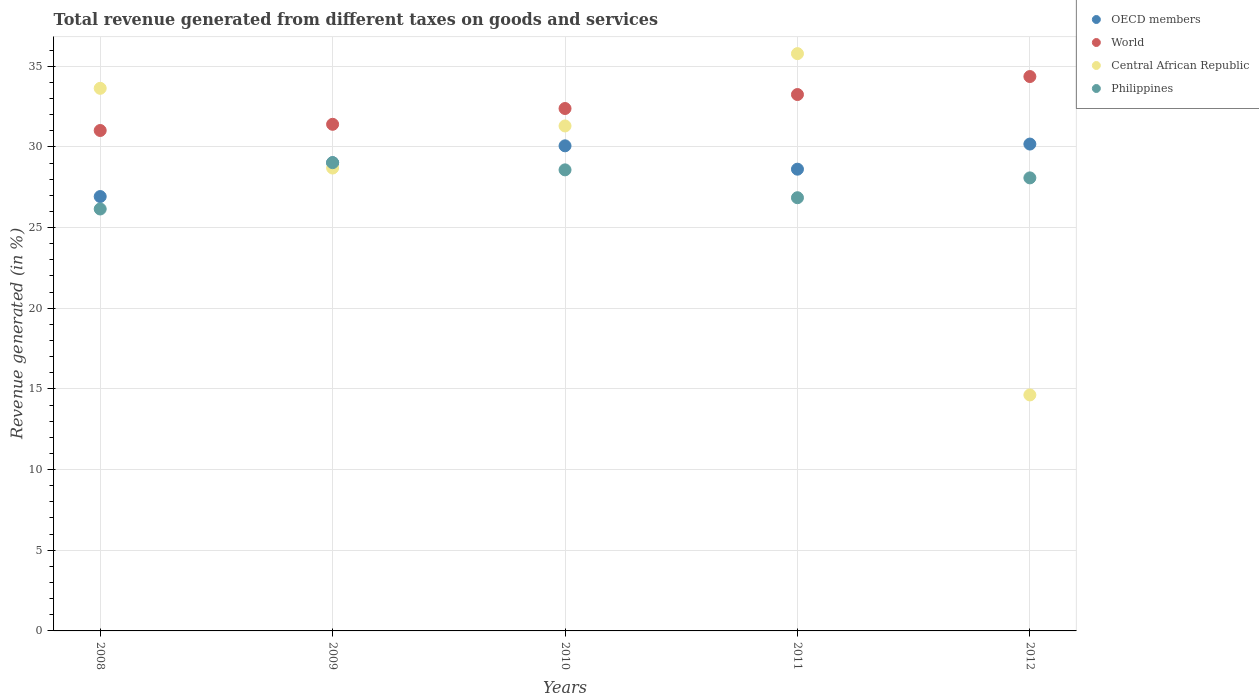What is the total revenue generated in World in 2012?
Your answer should be very brief. 34.36. Across all years, what is the maximum total revenue generated in Central African Republic?
Offer a very short reply. 35.78. Across all years, what is the minimum total revenue generated in Philippines?
Make the answer very short. 26.15. In which year was the total revenue generated in Central African Republic maximum?
Keep it short and to the point. 2011. What is the total total revenue generated in OECD members in the graph?
Your response must be concise. 144.8. What is the difference between the total revenue generated in Central African Republic in 2009 and that in 2010?
Keep it short and to the point. -2.61. What is the difference between the total revenue generated in OECD members in 2011 and the total revenue generated in Philippines in 2010?
Offer a terse response. 0.04. What is the average total revenue generated in Central African Republic per year?
Make the answer very short. 28.8. In the year 2011, what is the difference between the total revenue generated in Central African Republic and total revenue generated in Philippines?
Your answer should be compact. 8.93. In how many years, is the total revenue generated in OECD members greater than 32 %?
Your answer should be very brief. 0. What is the ratio of the total revenue generated in World in 2011 to that in 2012?
Your answer should be compact. 0.97. Is the total revenue generated in World in 2011 less than that in 2012?
Offer a terse response. Yes. Is the difference between the total revenue generated in Central African Republic in 2008 and 2010 greater than the difference between the total revenue generated in Philippines in 2008 and 2010?
Make the answer very short. Yes. What is the difference between the highest and the second highest total revenue generated in World?
Your response must be concise. 1.12. What is the difference between the highest and the lowest total revenue generated in Central African Republic?
Provide a short and direct response. 21.15. Does the total revenue generated in Philippines monotonically increase over the years?
Your answer should be very brief. No. How many years are there in the graph?
Your answer should be compact. 5. What is the difference between two consecutive major ticks on the Y-axis?
Provide a short and direct response. 5. Are the values on the major ticks of Y-axis written in scientific E-notation?
Offer a terse response. No. How many legend labels are there?
Ensure brevity in your answer.  4. What is the title of the graph?
Ensure brevity in your answer.  Total revenue generated from different taxes on goods and services. Does "Venezuela" appear as one of the legend labels in the graph?
Make the answer very short. No. What is the label or title of the Y-axis?
Ensure brevity in your answer.  Revenue generated (in %). What is the Revenue generated (in %) of OECD members in 2008?
Your answer should be very brief. 26.92. What is the Revenue generated (in %) in World in 2008?
Offer a terse response. 31.02. What is the Revenue generated (in %) of Central African Republic in 2008?
Offer a very short reply. 33.63. What is the Revenue generated (in %) of Philippines in 2008?
Offer a terse response. 26.15. What is the Revenue generated (in %) of OECD members in 2009?
Ensure brevity in your answer.  29.02. What is the Revenue generated (in %) in World in 2009?
Make the answer very short. 31.4. What is the Revenue generated (in %) of Central African Republic in 2009?
Ensure brevity in your answer.  28.69. What is the Revenue generated (in %) in Philippines in 2009?
Make the answer very short. 29.02. What is the Revenue generated (in %) in OECD members in 2010?
Your answer should be very brief. 30.07. What is the Revenue generated (in %) in World in 2010?
Make the answer very short. 32.38. What is the Revenue generated (in %) in Central African Republic in 2010?
Your response must be concise. 31.3. What is the Revenue generated (in %) of Philippines in 2010?
Keep it short and to the point. 28.58. What is the Revenue generated (in %) of OECD members in 2011?
Your answer should be very brief. 28.62. What is the Revenue generated (in %) of World in 2011?
Your answer should be very brief. 33.24. What is the Revenue generated (in %) in Central African Republic in 2011?
Make the answer very short. 35.78. What is the Revenue generated (in %) in Philippines in 2011?
Offer a terse response. 26.85. What is the Revenue generated (in %) in OECD members in 2012?
Your answer should be very brief. 30.17. What is the Revenue generated (in %) of World in 2012?
Your answer should be compact. 34.36. What is the Revenue generated (in %) in Central African Republic in 2012?
Your answer should be very brief. 14.63. What is the Revenue generated (in %) in Philippines in 2012?
Offer a terse response. 28.08. Across all years, what is the maximum Revenue generated (in %) of OECD members?
Provide a succinct answer. 30.17. Across all years, what is the maximum Revenue generated (in %) in World?
Ensure brevity in your answer.  34.36. Across all years, what is the maximum Revenue generated (in %) in Central African Republic?
Give a very brief answer. 35.78. Across all years, what is the maximum Revenue generated (in %) in Philippines?
Provide a short and direct response. 29.02. Across all years, what is the minimum Revenue generated (in %) in OECD members?
Offer a terse response. 26.92. Across all years, what is the minimum Revenue generated (in %) of World?
Your answer should be very brief. 31.02. Across all years, what is the minimum Revenue generated (in %) of Central African Republic?
Offer a terse response. 14.63. Across all years, what is the minimum Revenue generated (in %) of Philippines?
Your answer should be compact. 26.15. What is the total Revenue generated (in %) in OECD members in the graph?
Offer a terse response. 144.8. What is the total Revenue generated (in %) in World in the graph?
Your answer should be compact. 162.4. What is the total Revenue generated (in %) of Central African Republic in the graph?
Provide a succinct answer. 144.02. What is the total Revenue generated (in %) of Philippines in the graph?
Make the answer very short. 138.68. What is the difference between the Revenue generated (in %) of OECD members in 2008 and that in 2009?
Your response must be concise. -2.1. What is the difference between the Revenue generated (in %) in World in 2008 and that in 2009?
Your answer should be compact. -0.38. What is the difference between the Revenue generated (in %) in Central African Republic in 2008 and that in 2009?
Give a very brief answer. 4.94. What is the difference between the Revenue generated (in %) of Philippines in 2008 and that in 2009?
Your response must be concise. -2.87. What is the difference between the Revenue generated (in %) of OECD members in 2008 and that in 2010?
Your answer should be very brief. -3.14. What is the difference between the Revenue generated (in %) in World in 2008 and that in 2010?
Give a very brief answer. -1.36. What is the difference between the Revenue generated (in %) in Central African Republic in 2008 and that in 2010?
Offer a terse response. 2.33. What is the difference between the Revenue generated (in %) of Philippines in 2008 and that in 2010?
Offer a terse response. -2.42. What is the difference between the Revenue generated (in %) in OECD members in 2008 and that in 2011?
Your answer should be very brief. -1.7. What is the difference between the Revenue generated (in %) in World in 2008 and that in 2011?
Offer a terse response. -2.23. What is the difference between the Revenue generated (in %) of Central African Republic in 2008 and that in 2011?
Keep it short and to the point. -2.15. What is the difference between the Revenue generated (in %) of Philippines in 2008 and that in 2011?
Ensure brevity in your answer.  -0.7. What is the difference between the Revenue generated (in %) in OECD members in 2008 and that in 2012?
Offer a very short reply. -3.25. What is the difference between the Revenue generated (in %) in World in 2008 and that in 2012?
Keep it short and to the point. -3.34. What is the difference between the Revenue generated (in %) of Central African Republic in 2008 and that in 2012?
Offer a very short reply. 19. What is the difference between the Revenue generated (in %) in Philippines in 2008 and that in 2012?
Keep it short and to the point. -1.93. What is the difference between the Revenue generated (in %) in OECD members in 2009 and that in 2010?
Make the answer very short. -1.05. What is the difference between the Revenue generated (in %) in World in 2009 and that in 2010?
Your answer should be compact. -0.98. What is the difference between the Revenue generated (in %) in Central African Republic in 2009 and that in 2010?
Offer a very short reply. -2.61. What is the difference between the Revenue generated (in %) of Philippines in 2009 and that in 2010?
Your answer should be very brief. 0.45. What is the difference between the Revenue generated (in %) of OECD members in 2009 and that in 2011?
Provide a short and direct response. 0.4. What is the difference between the Revenue generated (in %) in World in 2009 and that in 2011?
Your answer should be compact. -1.85. What is the difference between the Revenue generated (in %) of Central African Republic in 2009 and that in 2011?
Offer a very short reply. -7.09. What is the difference between the Revenue generated (in %) of Philippines in 2009 and that in 2011?
Make the answer very short. 2.17. What is the difference between the Revenue generated (in %) of OECD members in 2009 and that in 2012?
Make the answer very short. -1.16. What is the difference between the Revenue generated (in %) of World in 2009 and that in 2012?
Your response must be concise. -2.96. What is the difference between the Revenue generated (in %) of Central African Republic in 2009 and that in 2012?
Ensure brevity in your answer.  14.06. What is the difference between the Revenue generated (in %) in Philippines in 2009 and that in 2012?
Your answer should be compact. 0.94. What is the difference between the Revenue generated (in %) of OECD members in 2010 and that in 2011?
Your answer should be compact. 1.45. What is the difference between the Revenue generated (in %) of World in 2010 and that in 2011?
Keep it short and to the point. -0.87. What is the difference between the Revenue generated (in %) in Central African Republic in 2010 and that in 2011?
Offer a very short reply. -4.48. What is the difference between the Revenue generated (in %) in Philippines in 2010 and that in 2011?
Ensure brevity in your answer.  1.73. What is the difference between the Revenue generated (in %) in OECD members in 2010 and that in 2012?
Make the answer very short. -0.11. What is the difference between the Revenue generated (in %) in World in 2010 and that in 2012?
Offer a terse response. -1.98. What is the difference between the Revenue generated (in %) of Central African Republic in 2010 and that in 2012?
Provide a short and direct response. 16.67. What is the difference between the Revenue generated (in %) of Philippines in 2010 and that in 2012?
Your response must be concise. 0.5. What is the difference between the Revenue generated (in %) in OECD members in 2011 and that in 2012?
Your answer should be very brief. -1.56. What is the difference between the Revenue generated (in %) of World in 2011 and that in 2012?
Make the answer very short. -1.11. What is the difference between the Revenue generated (in %) in Central African Republic in 2011 and that in 2012?
Offer a terse response. 21.15. What is the difference between the Revenue generated (in %) of Philippines in 2011 and that in 2012?
Keep it short and to the point. -1.23. What is the difference between the Revenue generated (in %) of OECD members in 2008 and the Revenue generated (in %) of World in 2009?
Provide a succinct answer. -4.48. What is the difference between the Revenue generated (in %) of OECD members in 2008 and the Revenue generated (in %) of Central African Republic in 2009?
Ensure brevity in your answer.  -1.77. What is the difference between the Revenue generated (in %) of OECD members in 2008 and the Revenue generated (in %) of Philippines in 2009?
Keep it short and to the point. -2.1. What is the difference between the Revenue generated (in %) of World in 2008 and the Revenue generated (in %) of Central African Republic in 2009?
Your answer should be compact. 2.33. What is the difference between the Revenue generated (in %) of World in 2008 and the Revenue generated (in %) of Philippines in 2009?
Provide a short and direct response. 1.99. What is the difference between the Revenue generated (in %) of Central African Republic in 2008 and the Revenue generated (in %) of Philippines in 2009?
Your answer should be compact. 4.61. What is the difference between the Revenue generated (in %) of OECD members in 2008 and the Revenue generated (in %) of World in 2010?
Provide a short and direct response. -5.46. What is the difference between the Revenue generated (in %) of OECD members in 2008 and the Revenue generated (in %) of Central African Republic in 2010?
Provide a short and direct response. -4.38. What is the difference between the Revenue generated (in %) in OECD members in 2008 and the Revenue generated (in %) in Philippines in 2010?
Your answer should be very brief. -1.65. What is the difference between the Revenue generated (in %) of World in 2008 and the Revenue generated (in %) of Central African Republic in 2010?
Make the answer very short. -0.28. What is the difference between the Revenue generated (in %) in World in 2008 and the Revenue generated (in %) in Philippines in 2010?
Give a very brief answer. 2.44. What is the difference between the Revenue generated (in %) in Central African Republic in 2008 and the Revenue generated (in %) in Philippines in 2010?
Ensure brevity in your answer.  5.05. What is the difference between the Revenue generated (in %) in OECD members in 2008 and the Revenue generated (in %) in World in 2011?
Offer a very short reply. -6.32. What is the difference between the Revenue generated (in %) in OECD members in 2008 and the Revenue generated (in %) in Central African Republic in 2011?
Give a very brief answer. -8.86. What is the difference between the Revenue generated (in %) in OECD members in 2008 and the Revenue generated (in %) in Philippines in 2011?
Make the answer very short. 0.07. What is the difference between the Revenue generated (in %) in World in 2008 and the Revenue generated (in %) in Central African Republic in 2011?
Provide a succinct answer. -4.76. What is the difference between the Revenue generated (in %) in World in 2008 and the Revenue generated (in %) in Philippines in 2011?
Provide a short and direct response. 4.17. What is the difference between the Revenue generated (in %) of Central African Republic in 2008 and the Revenue generated (in %) of Philippines in 2011?
Provide a short and direct response. 6.78. What is the difference between the Revenue generated (in %) of OECD members in 2008 and the Revenue generated (in %) of World in 2012?
Make the answer very short. -7.44. What is the difference between the Revenue generated (in %) in OECD members in 2008 and the Revenue generated (in %) in Central African Republic in 2012?
Offer a very short reply. 12.3. What is the difference between the Revenue generated (in %) in OECD members in 2008 and the Revenue generated (in %) in Philippines in 2012?
Your response must be concise. -1.16. What is the difference between the Revenue generated (in %) of World in 2008 and the Revenue generated (in %) of Central African Republic in 2012?
Keep it short and to the point. 16.39. What is the difference between the Revenue generated (in %) of World in 2008 and the Revenue generated (in %) of Philippines in 2012?
Offer a terse response. 2.94. What is the difference between the Revenue generated (in %) in Central African Republic in 2008 and the Revenue generated (in %) in Philippines in 2012?
Give a very brief answer. 5.55. What is the difference between the Revenue generated (in %) of OECD members in 2009 and the Revenue generated (in %) of World in 2010?
Give a very brief answer. -3.36. What is the difference between the Revenue generated (in %) in OECD members in 2009 and the Revenue generated (in %) in Central African Republic in 2010?
Keep it short and to the point. -2.28. What is the difference between the Revenue generated (in %) of OECD members in 2009 and the Revenue generated (in %) of Philippines in 2010?
Make the answer very short. 0.44. What is the difference between the Revenue generated (in %) in World in 2009 and the Revenue generated (in %) in Central African Republic in 2010?
Your answer should be very brief. 0.1. What is the difference between the Revenue generated (in %) in World in 2009 and the Revenue generated (in %) in Philippines in 2010?
Ensure brevity in your answer.  2.82. What is the difference between the Revenue generated (in %) of Central African Republic in 2009 and the Revenue generated (in %) of Philippines in 2010?
Your answer should be compact. 0.11. What is the difference between the Revenue generated (in %) of OECD members in 2009 and the Revenue generated (in %) of World in 2011?
Keep it short and to the point. -4.23. What is the difference between the Revenue generated (in %) of OECD members in 2009 and the Revenue generated (in %) of Central African Republic in 2011?
Your response must be concise. -6.76. What is the difference between the Revenue generated (in %) of OECD members in 2009 and the Revenue generated (in %) of Philippines in 2011?
Make the answer very short. 2.17. What is the difference between the Revenue generated (in %) of World in 2009 and the Revenue generated (in %) of Central African Republic in 2011?
Your answer should be compact. -4.38. What is the difference between the Revenue generated (in %) of World in 2009 and the Revenue generated (in %) of Philippines in 2011?
Provide a short and direct response. 4.55. What is the difference between the Revenue generated (in %) in Central African Republic in 2009 and the Revenue generated (in %) in Philippines in 2011?
Your response must be concise. 1.84. What is the difference between the Revenue generated (in %) in OECD members in 2009 and the Revenue generated (in %) in World in 2012?
Your answer should be very brief. -5.34. What is the difference between the Revenue generated (in %) in OECD members in 2009 and the Revenue generated (in %) in Central African Republic in 2012?
Your answer should be compact. 14.39. What is the difference between the Revenue generated (in %) in OECD members in 2009 and the Revenue generated (in %) in Philippines in 2012?
Offer a very short reply. 0.94. What is the difference between the Revenue generated (in %) of World in 2009 and the Revenue generated (in %) of Central African Republic in 2012?
Your response must be concise. 16.77. What is the difference between the Revenue generated (in %) in World in 2009 and the Revenue generated (in %) in Philippines in 2012?
Your answer should be very brief. 3.32. What is the difference between the Revenue generated (in %) of Central African Republic in 2009 and the Revenue generated (in %) of Philippines in 2012?
Your response must be concise. 0.61. What is the difference between the Revenue generated (in %) of OECD members in 2010 and the Revenue generated (in %) of World in 2011?
Provide a succinct answer. -3.18. What is the difference between the Revenue generated (in %) of OECD members in 2010 and the Revenue generated (in %) of Central African Republic in 2011?
Keep it short and to the point. -5.71. What is the difference between the Revenue generated (in %) of OECD members in 2010 and the Revenue generated (in %) of Philippines in 2011?
Provide a short and direct response. 3.22. What is the difference between the Revenue generated (in %) of World in 2010 and the Revenue generated (in %) of Central African Republic in 2011?
Your answer should be compact. -3.4. What is the difference between the Revenue generated (in %) of World in 2010 and the Revenue generated (in %) of Philippines in 2011?
Your response must be concise. 5.53. What is the difference between the Revenue generated (in %) of Central African Republic in 2010 and the Revenue generated (in %) of Philippines in 2011?
Ensure brevity in your answer.  4.45. What is the difference between the Revenue generated (in %) in OECD members in 2010 and the Revenue generated (in %) in World in 2012?
Your answer should be compact. -4.29. What is the difference between the Revenue generated (in %) in OECD members in 2010 and the Revenue generated (in %) in Central African Republic in 2012?
Keep it short and to the point. 15.44. What is the difference between the Revenue generated (in %) of OECD members in 2010 and the Revenue generated (in %) of Philippines in 2012?
Make the answer very short. 1.99. What is the difference between the Revenue generated (in %) in World in 2010 and the Revenue generated (in %) in Central African Republic in 2012?
Ensure brevity in your answer.  17.75. What is the difference between the Revenue generated (in %) in World in 2010 and the Revenue generated (in %) in Philippines in 2012?
Give a very brief answer. 4.3. What is the difference between the Revenue generated (in %) of Central African Republic in 2010 and the Revenue generated (in %) of Philippines in 2012?
Offer a very short reply. 3.22. What is the difference between the Revenue generated (in %) in OECD members in 2011 and the Revenue generated (in %) in World in 2012?
Provide a succinct answer. -5.74. What is the difference between the Revenue generated (in %) of OECD members in 2011 and the Revenue generated (in %) of Central African Republic in 2012?
Give a very brief answer. 13.99. What is the difference between the Revenue generated (in %) in OECD members in 2011 and the Revenue generated (in %) in Philippines in 2012?
Give a very brief answer. 0.54. What is the difference between the Revenue generated (in %) of World in 2011 and the Revenue generated (in %) of Central African Republic in 2012?
Provide a succinct answer. 18.62. What is the difference between the Revenue generated (in %) in World in 2011 and the Revenue generated (in %) in Philippines in 2012?
Your response must be concise. 5.17. What is the difference between the Revenue generated (in %) of Central African Republic in 2011 and the Revenue generated (in %) of Philippines in 2012?
Ensure brevity in your answer.  7.7. What is the average Revenue generated (in %) of OECD members per year?
Make the answer very short. 28.96. What is the average Revenue generated (in %) in World per year?
Offer a terse response. 32.48. What is the average Revenue generated (in %) of Central African Republic per year?
Give a very brief answer. 28.8. What is the average Revenue generated (in %) in Philippines per year?
Ensure brevity in your answer.  27.74. In the year 2008, what is the difference between the Revenue generated (in %) in OECD members and Revenue generated (in %) in World?
Give a very brief answer. -4.09. In the year 2008, what is the difference between the Revenue generated (in %) of OECD members and Revenue generated (in %) of Central African Republic?
Ensure brevity in your answer.  -6.71. In the year 2008, what is the difference between the Revenue generated (in %) of OECD members and Revenue generated (in %) of Philippines?
Give a very brief answer. 0.77. In the year 2008, what is the difference between the Revenue generated (in %) of World and Revenue generated (in %) of Central African Republic?
Your response must be concise. -2.61. In the year 2008, what is the difference between the Revenue generated (in %) in World and Revenue generated (in %) in Philippines?
Offer a terse response. 4.86. In the year 2008, what is the difference between the Revenue generated (in %) in Central African Republic and Revenue generated (in %) in Philippines?
Keep it short and to the point. 7.48. In the year 2009, what is the difference between the Revenue generated (in %) of OECD members and Revenue generated (in %) of World?
Your answer should be compact. -2.38. In the year 2009, what is the difference between the Revenue generated (in %) in OECD members and Revenue generated (in %) in Central African Republic?
Provide a succinct answer. 0.33. In the year 2009, what is the difference between the Revenue generated (in %) in OECD members and Revenue generated (in %) in Philippines?
Your answer should be compact. -0. In the year 2009, what is the difference between the Revenue generated (in %) in World and Revenue generated (in %) in Central African Republic?
Make the answer very short. 2.71. In the year 2009, what is the difference between the Revenue generated (in %) of World and Revenue generated (in %) of Philippines?
Provide a succinct answer. 2.38. In the year 2009, what is the difference between the Revenue generated (in %) of Central African Republic and Revenue generated (in %) of Philippines?
Give a very brief answer. -0.33. In the year 2010, what is the difference between the Revenue generated (in %) of OECD members and Revenue generated (in %) of World?
Make the answer very short. -2.31. In the year 2010, what is the difference between the Revenue generated (in %) in OECD members and Revenue generated (in %) in Central African Republic?
Keep it short and to the point. -1.23. In the year 2010, what is the difference between the Revenue generated (in %) in OECD members and Revenue generated (in %) in Philippines?
Make the answer very short. 1.49. In the year 2010, what is the difference between the Revenue generated (in %) of World and Revenue generated (in %) of Central African Republic?
Your response must be concise. 1.08. In the year 2010, what is the difference between the Revenue generated (in %) in World and Revenue generated (in %) in Philippines?
Offer a very short reply. 3.8. In the year 2010, what is the difference between the Revenue generated (in %) of Central African Republic and Revenue generated (in %) of Philippines?
Keep it short and to the point. 2.72. In the year 2011, what is the difference between the Revenue generated (in %) in OECD members and Revenue generated (in %) in World?
Make the answer very short. -4.63. In the year 2011, what is the difference between the Revenue generated (in %) in OECD members and Revenue generated (in %) in Central African Republic?
Your response must be concise. -7.16. In the year 2011, what is the difference between the Revenue generated (in %) of OECD members and Revenue generated (in %) of Philippines?
Ensure brevity in your answer.  1.77. In the year 2011, what is the difference between the Revenue generated (in %) of World and Revenue generated (in %) of Central African Republic?
Your response must be concise. -2.53. In the year 2011, what is the difference between the Revenue generated (in %) in World and Revenue generated (in %) in Philippines?
Offer a very short reply. 6.4. In the year 2011, what is the difference between the Revenue generated (in %) of Central African Republic and Revenue generated (in %) of Philippines?
Your answer should be compact. 8.93. In the year 2012, what is the difference between the Revenue generated (in %) in OECD members and Revenue generated (in %) in World?
Offer a terse response. -4.18. In the year 2012, what is the difference between the Revenue generated (in %) of OECD members and Revenue generated (in %) of Central African Republic?
Offer a terse response. 15.55. In the year 2012, what is the difference between the Revenue generated (in %) in OECD members and Revenue generated (in %) in Philippines?
Provide a succinct answer. 2.1. In the year 2012, what is the difference between the Revenue generated (in %) in World and Revenue generated (in %) in Central African Republic?
Keep it short and to the point. 19.73. In the year 2012, what is the difference between the Revenue generated (in %) of World and Revenue generated (in %) of Philippines?
Make the answer very short. 6.28. In the year 2012, what is the difference between the Revenue generated (in %) of Central African Republic and Revenue generated (in %) of Philippines?
Provide a short and direct response. -13.45. What is the ratio of the Revenue generated (in %) of OECD members in 2008 to that in 2009?
Provide a succinct answer. 0.93. What is the ratio of the Revenue generated (in %) of Central African Republic in 2008 to that in 2009?
Your response must be concise. 1.17. What is the ratio of the Revenue generated (in %) in Philippines in 2008 to that in 2009?
Your answer should be compact. 0.9. What is the ratio of the Revenue generated (in %) of OECD members in 2008 to that in 2010?
Offer a terse response. 0.9. What is the ratio of the Revenue generated (in %) in World in 2008 to that in 2010?
Offer a terse response. 0.96. What is the ratio of the Revenue generated (in %) of Central African Republic in 2008 to that in 2010?
Offer a very short reply. 1.07. What is the ratio of the Revenue generated (in %) of Philippines in 2008 to that in 2010?
Your answer should be compact. 0.92. What is the ratio of the Revenue generated (in %) in OECD members in 2008 to that in 2011?
Keep it short and to the point. 0.94. What is the ratio of the Revenue generated (in %) in World in 2008 to that in 2011?
Your answer should be compact. 0.93. What is the ratio of the Revenue generated (in %) in Central African Republic in 2008 to that in 2011?
Offer a terse response. 0.94. What is the ratio of the Revenue generated (in %) in Philippines in 2008 to that in 2011?
Keep it short and to the point. 0.97. What is the ratio of the Revenue generated (in %) of OECD members in 2008 to that in 2012?
Your response must be concise. 0.89. What is the ratio of the Revenue generated (in %) in World in 2008 to that in 2012?
Your answer should be very brief. 0.9. What is the ratio of the Revenue generated (in %) of Central African Republic in 2008 to that in 2012?
Your response must be concise. 2.3. What is the ratio of the Revenue generated (in %) in Philippines in 2008 to that in 2012?
Give a very brief answer. 0.93. What is the ratio of the Revenue generated (in %) in OECD members in 2009 to that in 2010?
Ensure brevity in your answer.  0.97. What is the ratio of the Revenue generated (in %) of World in 2009 to that in 2010?
Give a very brief answer. 0.97. What is the ratio of the Revenue generated (in %) in Philippines in 2009 to that in 2010?
Give a very brief answer. 1.02. What is the ratio of the Revenue generated (in %) in OECD members in 2009 to that in 2011?
Your answer should be very brief. 1.01. What is the ratio of the Revenue generated (in %) of World in 2009 to that in 2011?
Offer a very short reply. 0.94. What is the ratio of the Revenue generated (in %) in Central African Republic in 2009 to that in 2011?
Offer a very short reply. 0.8. What is the ratio of the Revenue generated (in %) of Philippines in 2009 to that in 2011?
Offer a very short reply. 1.08. What is the ratio of the Revenue generated (in %) in OECD members in 2009 to that in 2012?
Your answer should be compact. 0.96. What is the ratio of the Revenue generated (in %) in World in 2009 to that in 2012?
Your response must be concise. 0.91. What is the ratio of the Revenue generated (in %) in Central African Republic in 2009 to that in 2012?
Offer a very short reply. 1.96. What is the ratio of the Revenue generated (in %) of Philippines in 2009 to that in 2012?
Keep it short and to the point. 1.03. What is the ratio of the Revenue generated (in %) in OECD members in 2010 to that in 2011?
Keep it short and to the point. 1.05. What is the ratio of the Revenue generated (in %) in World in 2010 to that in 2011?
Keep it short and to the point. 0.97. What is the ratio of the Revenue generated (in %) in Central African Republic in 2010 to that in 2011?
Offer a very short reply. 0.87. What is the ratio of the Revenue generated (in %) in Philippines in 2010 to that in 2011?
Offer a very short reply. 1.06. What is the ratio of the Revenue generated (in %) of World in 2010 to that in 2012?
Keep it short and to the point. 0.94. What is the ratio of the Revenue generated (in %) in Central African Republic in 2010 to that in 2012?
Provide a short and direct response. 2.14. What is the ratio of the Revenue generated (in %) of Philippines in 2010 to that in 2012?
Offer a very short reply. 1.02. What is the ratio of the Revenue generated (in %) of OECD members in 2011 to that in 2012?
Ensure brevity in your answer.  0.95. What is the ratio of the Revenue generated (in %) of World in 2011 to that in 2012?
Offer a very short reply. 0.97. What is the ratio of the Revenue generated (in %) in Central African Republic in 2011 to that in 2012?
Ensure brevity in your answer.  2.45. What is the ratio of the Revenue generated (in %) of Philippines in 2011 to that in 2012?
Your answer should be compact. 0.96. What is the difference between the highest and the second highest Revenue generated (in %) in OECD members?
Provide a short and direct response. 0.11. What is the difference between the highest and the second highest Revenue generated (in %) of World?
Keep it short and to the point. 1.11. What is the difference between the highest and the second highest Revenue generated (in %) in Central African Republic?
Keep it short and to the point. 2.15. What is the difference between the highest and the second highest Revenue generated (in %) in Philippines?
Make the answer very short. 0.45. What is the difference between the highest and the lowest Revenue generated (in %) of OECD members?
Your answer should be compact. 3.25. What is the difference between the highest and the lowest Revenue generated (in %) of World?
Provide a succinct answer. 3.34. What is the difference between the highest and the lowest Revenue generated (in %) of Central African Republic?
Give a very brief answer. 21.15. What is the difference between the highest and the lowest Revenue generated (in %) of Philippines?
Give a very brief answer. 2.87. 